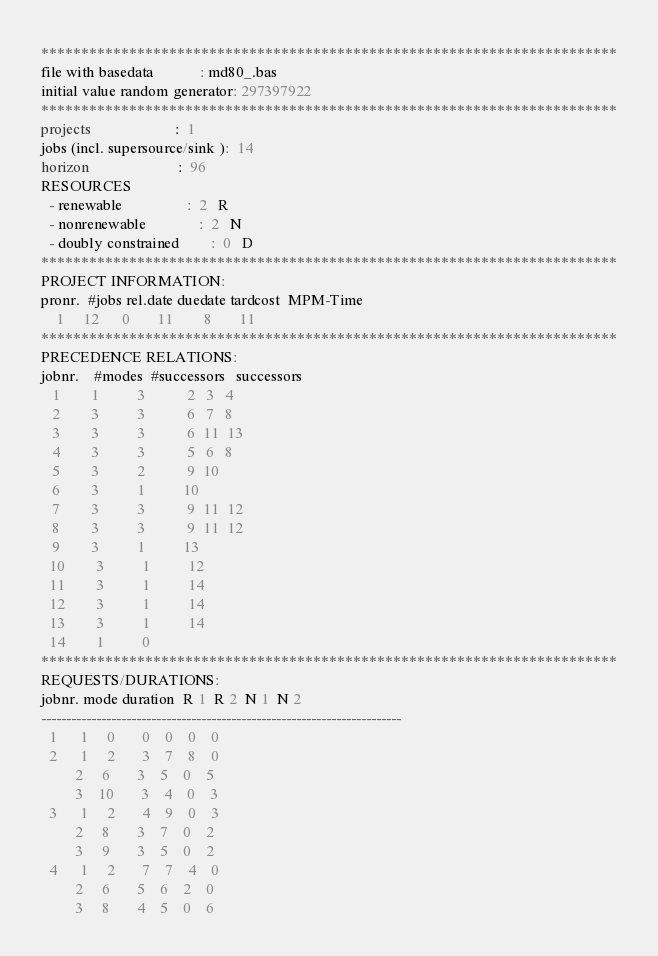<code> <loc_0><loc_0><loc_500><loc_500><_ObjectiveC_>************************************************************************
file with basedata            : md80_.bas
initial value random generator: 297397922
************************************************************************
projects                      :  1
jobs (incl. supersource/sink ):  14
horizon                       :  96
RESOURCES
  - renewable                 :  2   R
  - nonrenewable              :  2   N
  - doubly constrained        :  0   D
************************************************************************
PROJECT INFORMATION:
pronr.  #jobs rel.date duedate tardcost  MPM-Time
    1     12      0       11        8       11
************************************************************************
PRECEDENCE RELATIONS:
jobnr.    #modes  #successors   successors
   1        1          3           2   3   4
   2        3          3           6   7   8
   3        3          3           6  11  13
   4        3          3           5   6   8
   5        3          2           9  10
   6        3          1          10
   7        3          3           9  11  12
   8        3          3           9  11  12
   9        3          1          13
  10        3          1          12
  11        3          1          14
  12        3          1          14
  13        3          1          14
  14        1          0        
************************************************************************
REQUESTS/DURATIONS:
jobnr. mode duration  R 1  R 2  N 1  N 2
------------------------------------------------------------------------
  1      1     0       0    0    0    0
  2      1     2       3    7    8    0
         2     6       3    5    0    5
         3    10       3    4    0    3
  3      1     2       4    9    0    3
         2     8       3    7    0    2
         3     9       3    5    0    2
  4      1     2       7    7    4    0
         2     6       5    6    2    0
         3     8       4    5    0    6</code> 